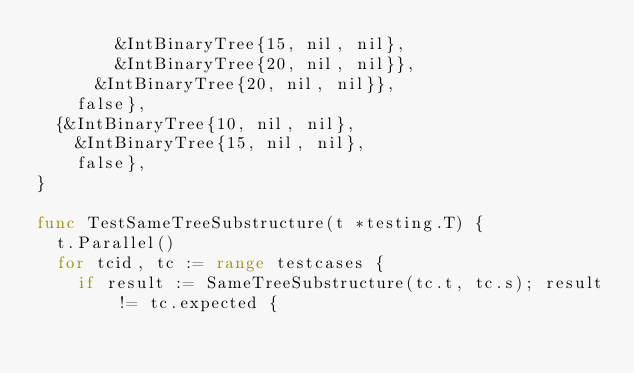Convert code to text. <code><loc_0><loc_0><loc_500><loc_500><_Go_>				&IntBinaryTree{15, nil, nil},
				&IntBinaryTree{20, nil, nil}},
			&IntBinaryTree{20, nil, nil}},
		false},
	{&IntBinaryTree{10, nil, nil},
		&IntBinaryTree{15, nil, nil},
		false},
}

func TestSameTreeSubstructure(t *testing.T) {
	t.Parallel()
	for tcid, tc := range testcases {
		if result := SameTreeSubstructure(tc.t, tc.s); result != tc.expected {</code> 